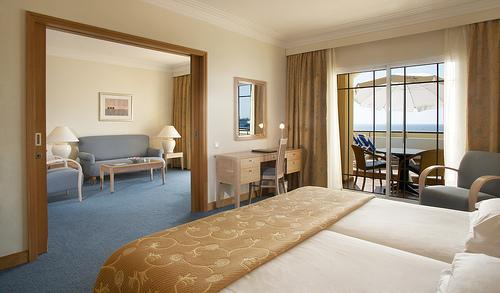Using the given information, write a sentence about one unique item in the room. There is a light blue sofa seat with dimensions 90x90 located at position (75, 134) in the image. Select a small object in the image and describe its location and appearance. A lit lightbulb is present in the image, located at position (278, 121) with dimensions 7x7. Choose any object, describe its function and provide its location coordinates. A white patio umbrella provides shade, located at position (352, 73) with dimensions 100x100. Identify a unique feature of the hotel room in the image and provide the necessary details. The hotel room features a mirror with a wooden frame, located at position (232, 76) and having dimensions 35x35. What is the largest object in the image? Describe its appearance and provide its dimensions. The largest object in the image is a yellow patterned blanket at the foot of a bed, having dimensions 285x285 and located at position (91, 183). Mention an object with a color adjective in its description and provide details about its appearance and location. The image features a light blue chair with wooden arms, located next to a bed at position (416, 148) and having dimensions 82x82. Describe an artwork in the image and provide its location details. There is a painting on the wall in the living room of the hotel suite, located at position (95, 91) with dimensions 40x40. Describe a piece of furniture present in the image that is covered in fabric and mention its location. A light blue sofa seat, located at position (75, 134) with dimensions 90x90 is covered in fabric. Select two objects of the same color and provide necessary details about their appearances and positions. A light blue sofa seat (75, 134) with dimensions 90x90 and a light blue chair (418, 150) with dimensions 80x80 are both present in the image. Mention a piece of furniture in the room and describe its position and physical appearance. A wooden desk and chair are located at position (215, 138) in the corner of the room, having dimensions 91x91. 